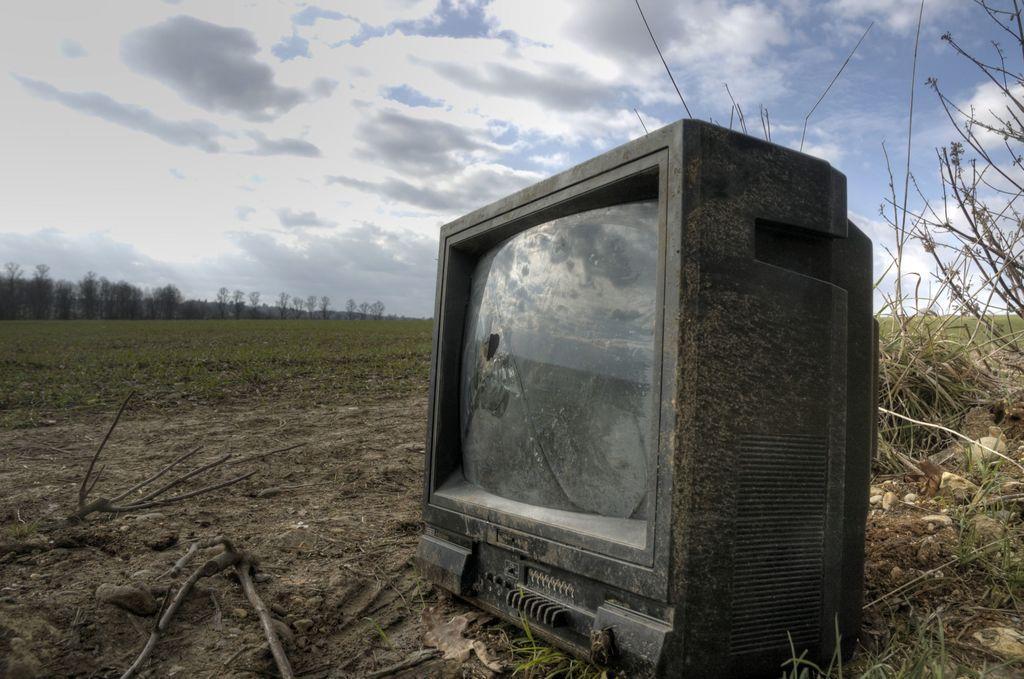Describe this image in one or two sentences. This is a television, which is damaged. I can see the branches and plants. This is the grass. In the background, I can see the trees. These are the clouds in the sky. 